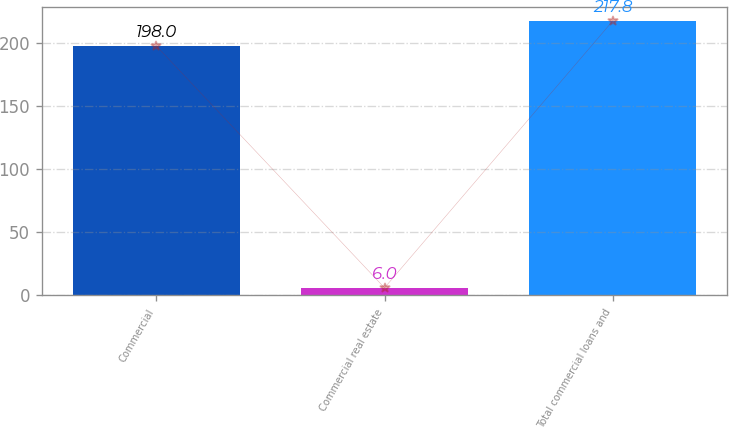Convert chart to OTSL. <chart><loc_0><loc_0><loc_500><loc_500><bar_chart><fcel>Commercial<fcel>Commercial real estate<fcel>Total commercial loans and<nl><fcel>198<fcel>6<fcel>217.8<nl></chart> 